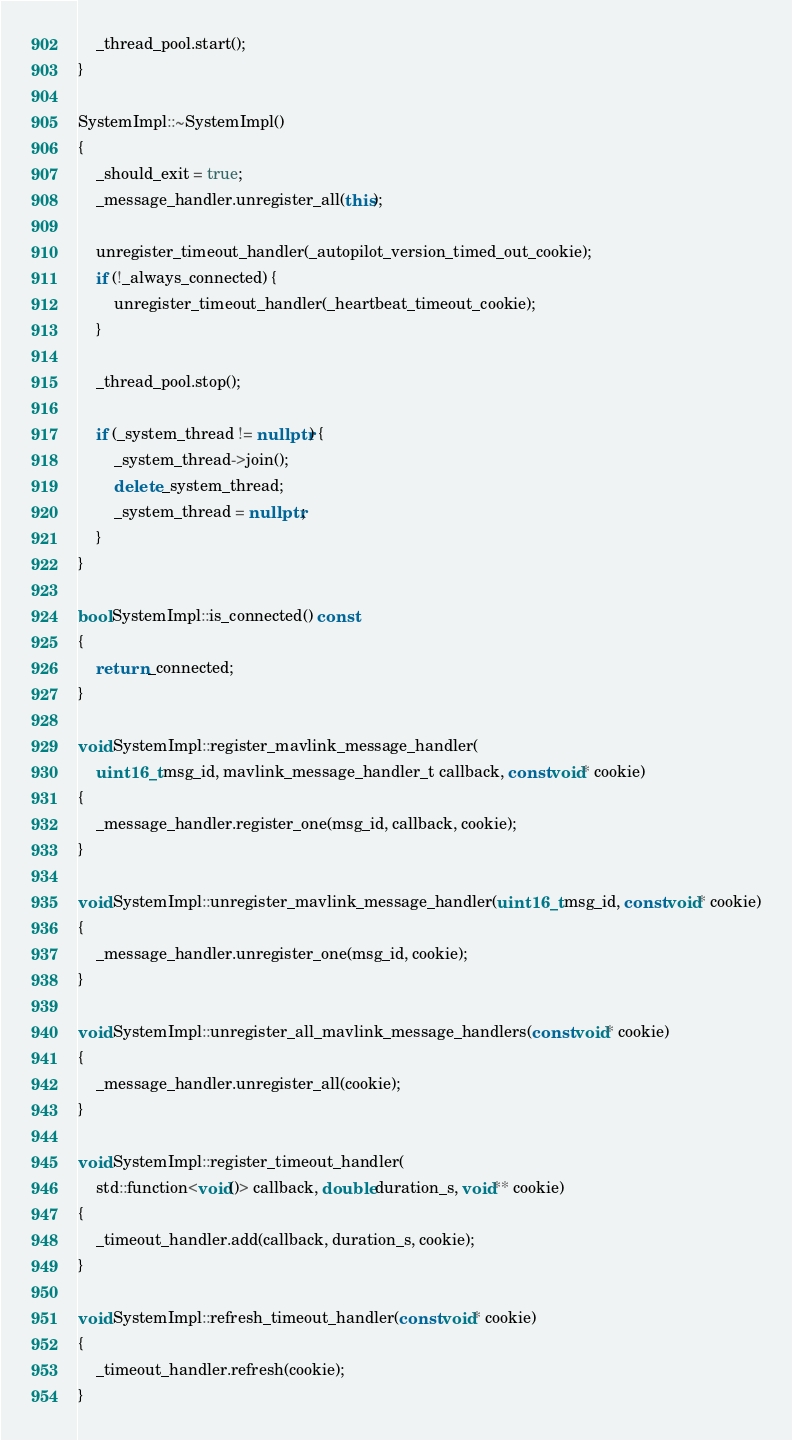Convert code to text. <code><loc_0><loc_0><loc_500><loc_500><_C++_>    _thread_pool.start();
}

SystemImpl::~SystemImpl()
{
    _should_exit = true;
    _message_handler.unregister_all(this);

    unregister_timeout_handler(_autopilot_version_timed_out_cookie);
    if (!_always_connected) {
        unregister_timeout_handler(_heartbeat_timeout_cookie);
    }

    _thread_pool.stop();

    if (_system_thread != nullptr) {
        _system_thread->join();
        delete _system_thread;
        _system_thread = nullptr;
    }
}

bool SystemImpl::is_connected() const
{
    return _connected;
}

void SystemImpl::register_mavlink_message_handler(
    uint16_t msg_id, mavlink_message_handler_t callback, const void* cookie)
{
    _message_handler.register_one(msg_id, callback, cookie);
}

void SystemImpl::unregister_mavlink_message_handler(uint16_t msg_id, const void* cookie)
{
    _message_handler.unregister_one(msg_id, cookie);
}

void SystemImpl::unregister_all_mavlink_message_handlers(const void* cookie)
{
    _message_handler.unregister_all(cookie);
}

void SystemImpl::register_timeout_handler(
    std::function<void()> callback, double duration_s, void** cookie)
{
    _timeout_handler.add(callback, duration_s, cookie);
}

void SystemImpl::refresh_timeout_handler(const void* cookie)
{
    _timeout_handler.refresh(cookie);
}
</code> 